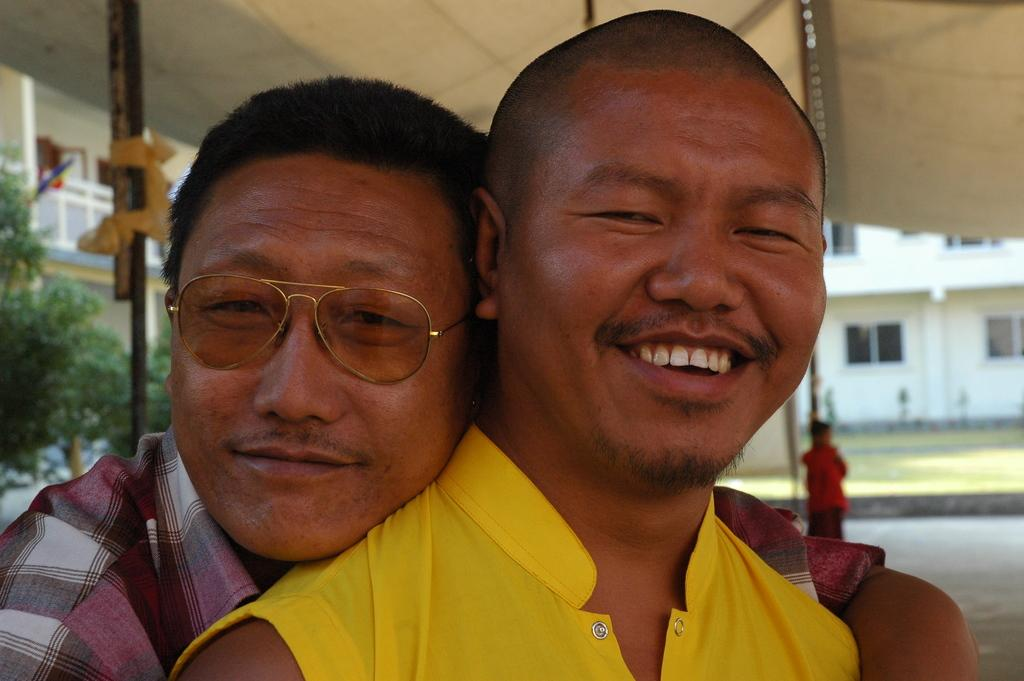How many people are in the image? There are two persons in the image. What is a distinguishing feature of the person on the left? The person on the left is wearing glasses (specs). What can be seen in the background of the image? There is a building with windows and trees in the background of the image. What type of pen is the person on the right using in the image? There is no pen visible in the image, and the person on the right is not using any pen. Is the image taken during a hot day? The provided facts do not mention the weather or temperature, so it cannot be determined if the image was taken during a hot day. 